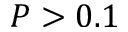<formula> <loc_0><loc_0><loc_500><loc_500>P > 0 . 1</formula> 